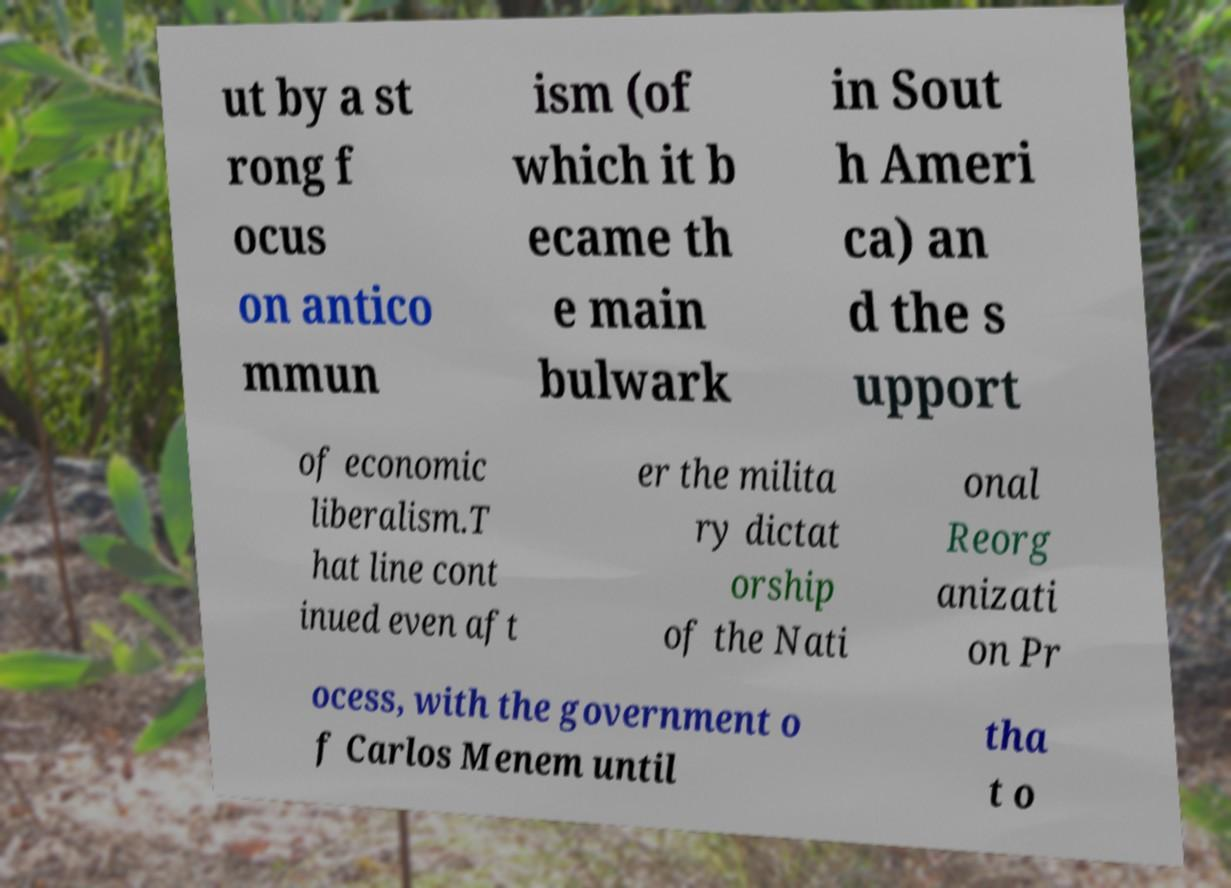Can you accurately transcribe the text from the provided image for me? ut by a st rong f ocus on antico mmun ism (of which it b ecame th e main bulwark in Sout h Ameri ca) an d the s upport of economic liberalism.T hat line cont inued even aft er the milita ry dictat orship of the Nati onal Reorg anizati on Pr ocess, with the government o f Carlos Menem until tha t o 